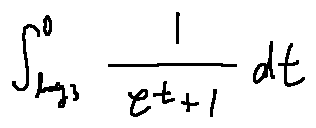<formula> <loc_0><loc_0><loc_500><loc_500>\int \lim i t s _ { \log 3 } ^ { 0 } \frac { 1 } { e ^ { t } + 1 } d t</formula> 